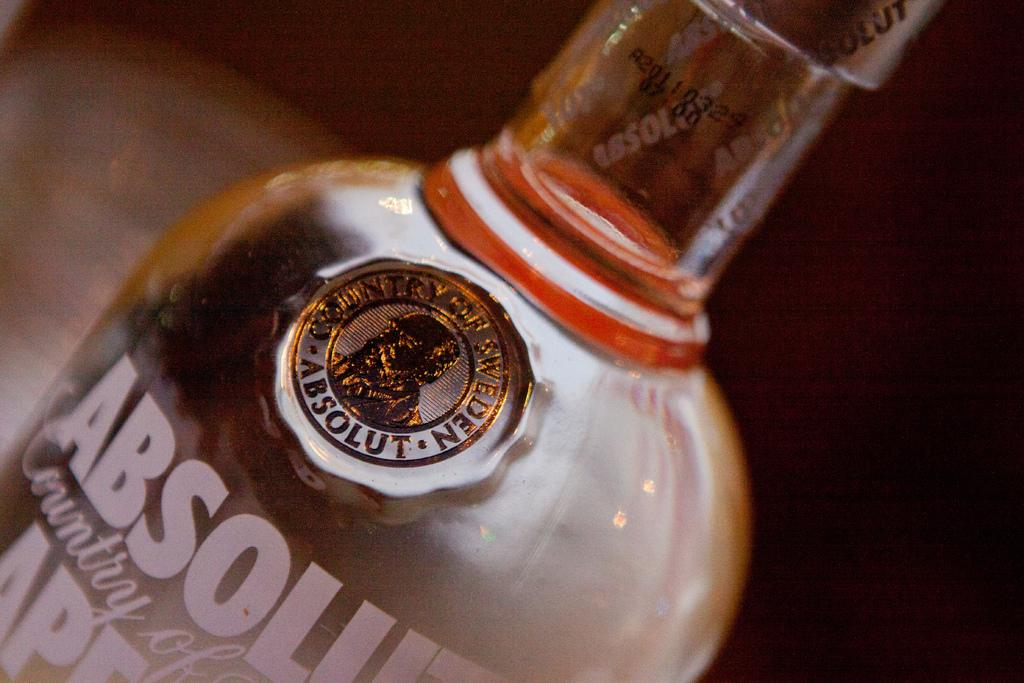<image>
Summarize the visual content of the image. A dark bottle of country Absolute may be a wine or beer 